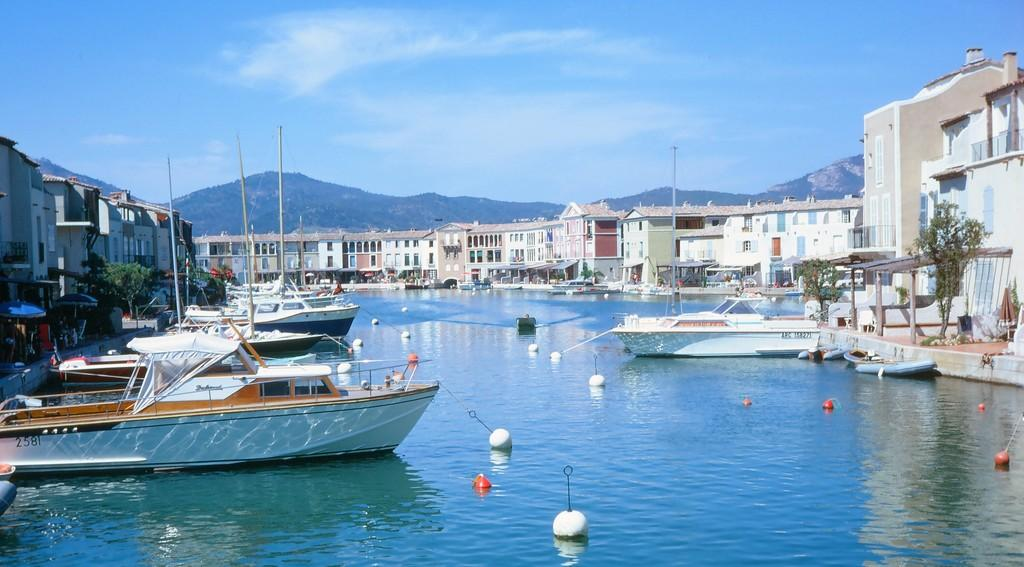What is located in the center of the image? There are boats and poles in the center of the image. What can be seen in the background of the image? The sky, clouds, trees, buildings, and water are visible in the background of the image. Are there any poles present in the background of the image? Yes, there are poles in the background of the image. What type of cart is being pulled by a potato in the image? There is no cart or potato present in the image. Can you describe the hand gestures of the people in the image? There are no people present in the image, so hand gestures cannot be described. 